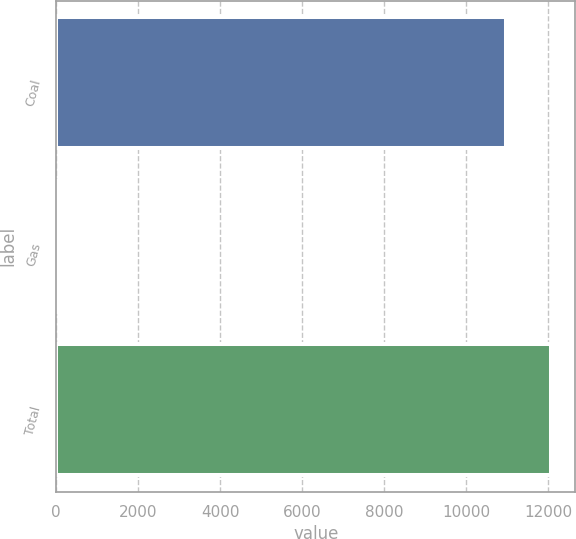Convert chart to OTSL. <chart><loc_0><loc_0><loc_500><loc_500><bar_chart><fcel>Coal<fcel>Gas<fcel>Total<nl><fcel>10968<fcel>68<fcel>12064.8<nl></chart> 